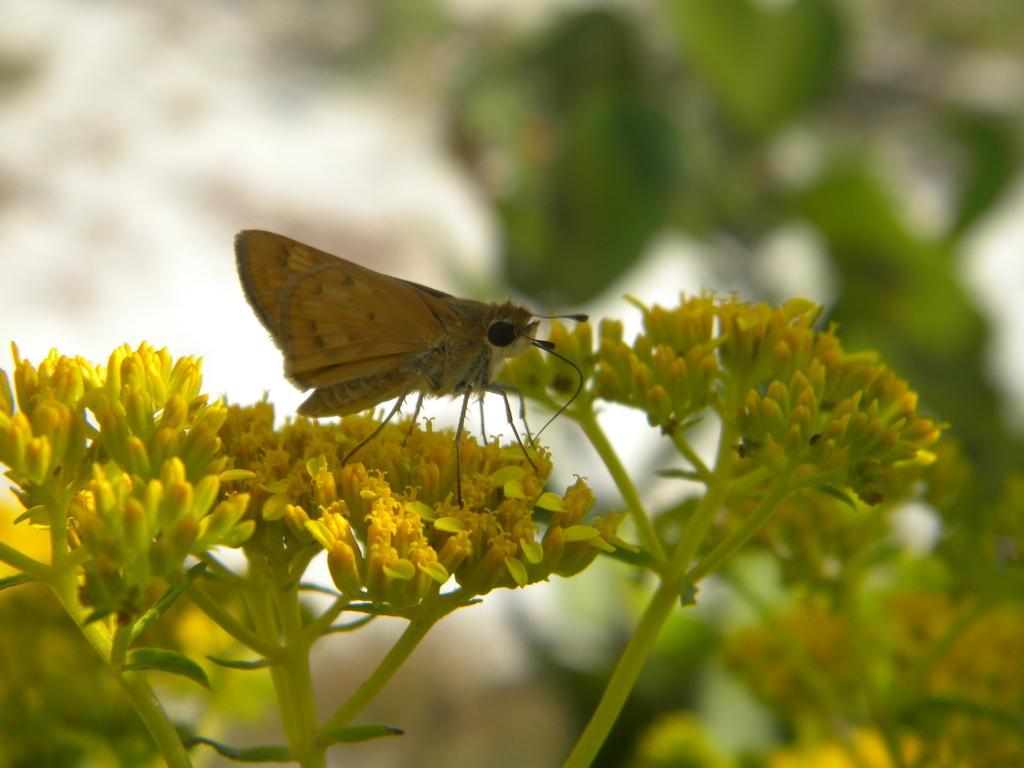Please provide a concise description of this image. In this picture I can see yellow color flowers and a butterfly on the flower. it is yellow in color and looks like trees on the back. 